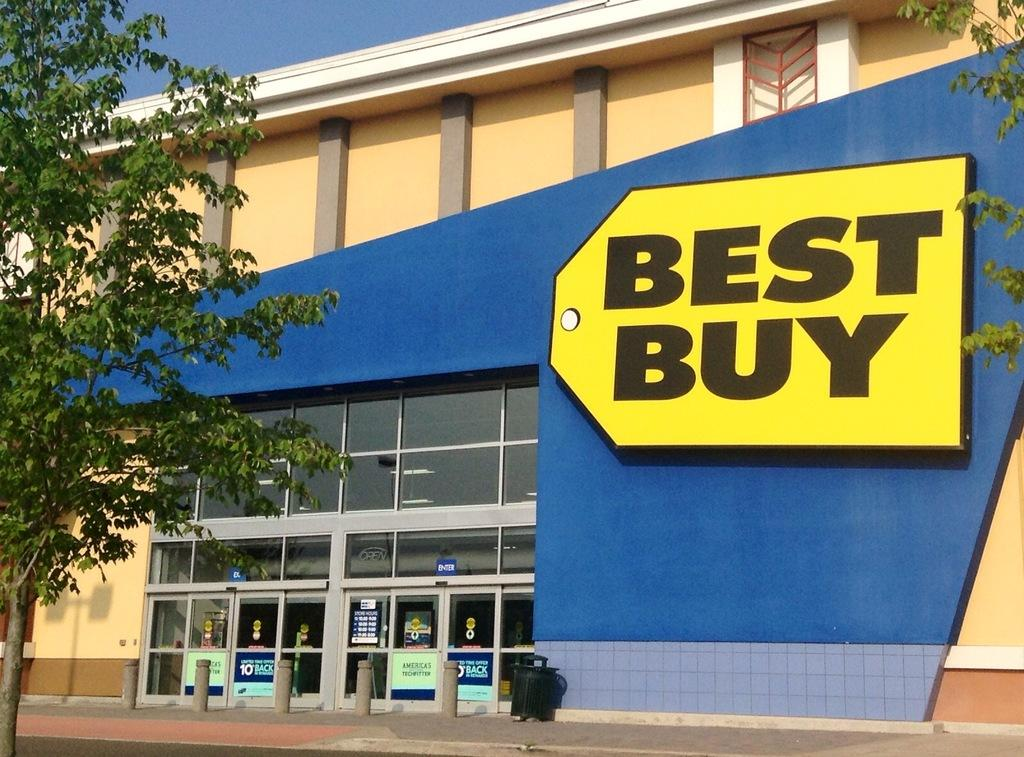What type of structure is present in the image? There is a building in the image. What can be seen on the building? The building has a tag symbol. What type of windows are on the building? The building has glass windows. What is located in front of the building? There is a footpath in front of the building. What type of vegetation is near the building? There is a tree near the building. What is visible above the building? The sky is visible above the building. What type of apple is growing on the root near the building? There is no apple or root present in the image; it only features a building, a tree, and a footpath. 